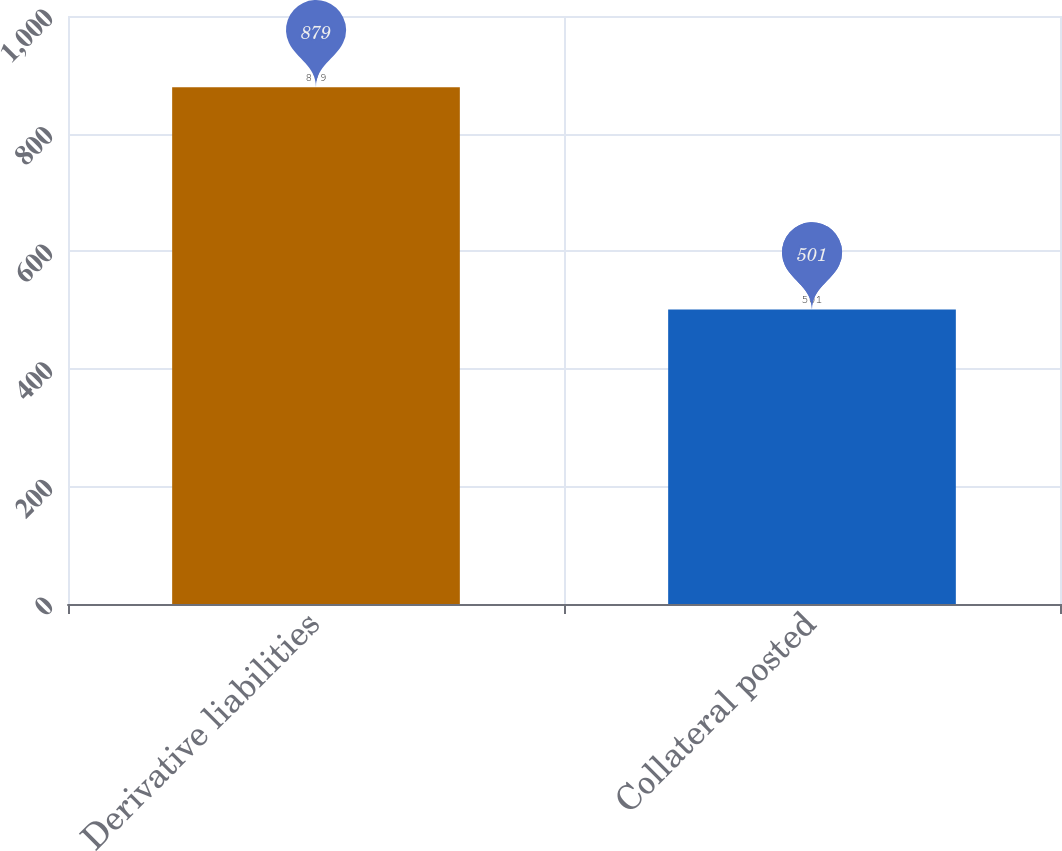<chart> <loc_0><loc_0><loc_500><loc_500><bar_chart><fcel>Derivative liabilities<fcel>Collateral posted<nl><fcel>879<fcel>501<nl></chart> 